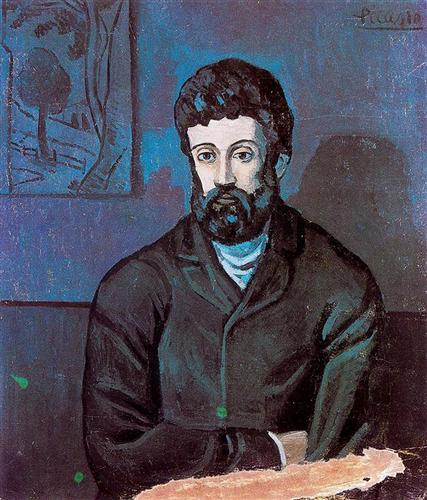Discuss the significance of the tree sketch in the background. The presence of the tree sketch in the background of the painting may symbolize growth, life, or nature's enduring presence. It serves as a stark contrast to the subject's somber expression, possibly offering a window into his thoughts or emotions. The tree may represent the subject's connection to the outdoors or his aspirations and thoughts branching out beyond his immediate surroundings. Its sketch-like quality suggests it's an integral yet subtle backdrop to the subject's life story. 